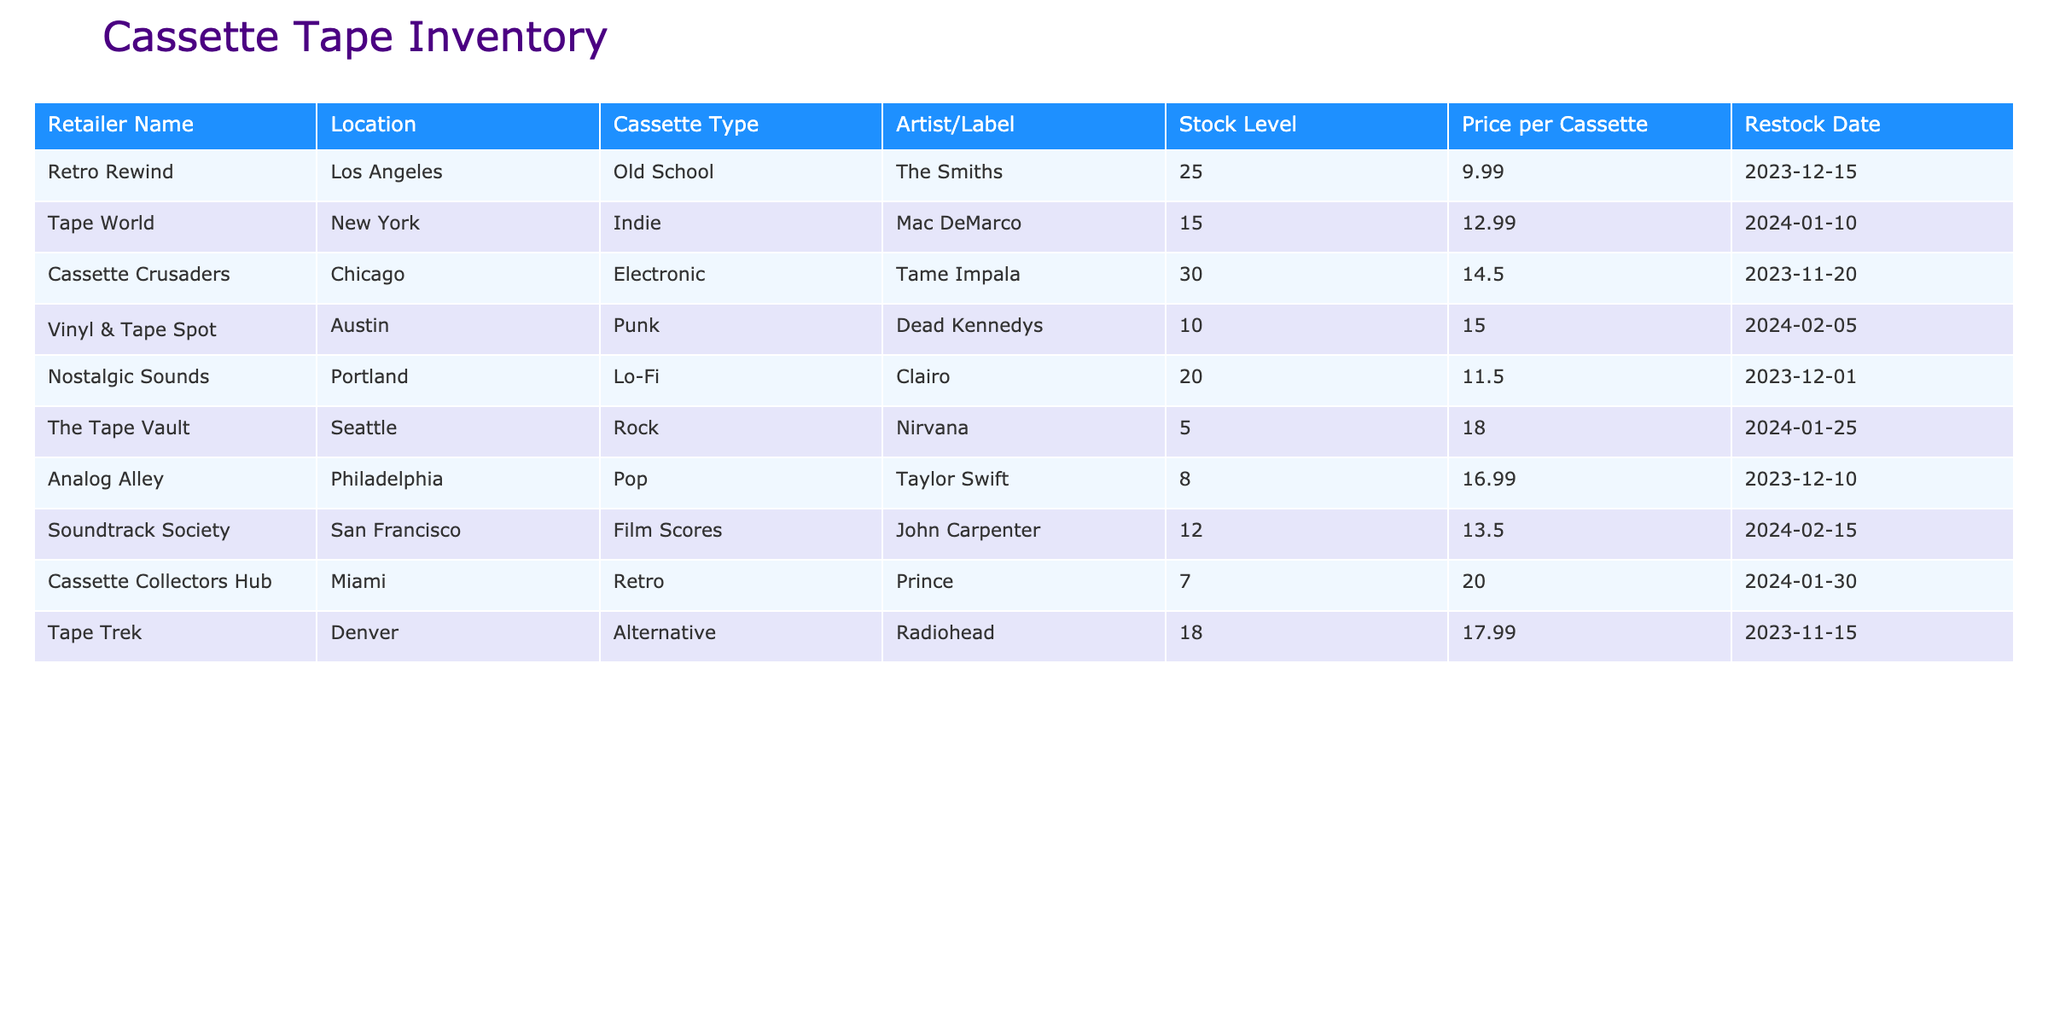What is the stock level of the cassette titled "Tame Impala"? Looking at the table, I can find the row corresponding to the artist "Tame Impala" under the "Cassette Type" of "Electronic". The stock level listed there is 30.
Answer: 30 How much does the cassette by "Dead Kennedys" cost? In the table, I find "Dead Kennedys" listed under the "Punk" cassette type. The price per cassette for this item is shown as 15.00.
Answer: 15.00 Are there more than 20 cassettes available at "Tape World"? Checking the row for "Tape World", I see that the stock level is 15, which is less than 20. Therefore, the statement is false.
Answer: No Which retailer has the highest stock level? By looking through the "Stock Level" column in the table, I identify the highest value, which belongs to "Cassette Crusaders" with a stock level of 30.
Answer: Cassette Crusaders What is the total stock level of cassettes available in "Los Angeles"? In the table, the retailer in "Los Angeles" is "Retro Rewind" with a stock level of 25. Since it's the only retailer from that location, the total stock level is simply 25.
Answer: 25 How many cassettes by "Radiohead" are currently in stock? I look for "Radiohead" in the "Cassette Type" column under "Alternative". The table shows that the stock level for Radiohead is 18.
Answer: 18 Is there a cassette by "Clairo" that costs less than 12.00? The row for "Clairo" shows the price per cassette as 11.50, which is indeed less than 12.00. Hence, the statement is true.
Answer: Yes Which cassette type has the lowest number of pieces available? As I scan through the stock levels, I find that "The Tape Vault" has a stock level of 5, which is the lowest compared to other entries.
Answer: Rock What is the average price of all cassettes listed in the table? To find the average price, I add up all the prices: (9.99 + 12.99 + 14.50 + 15.00 + 11.50 + 18.00 + 16.99 + 13.50 + 20.00 + 17.99) = 130.47. Since there are 10 items, I divide 130.47 by 10, resulting in an average price of 13.05.
Answer: 13.05 